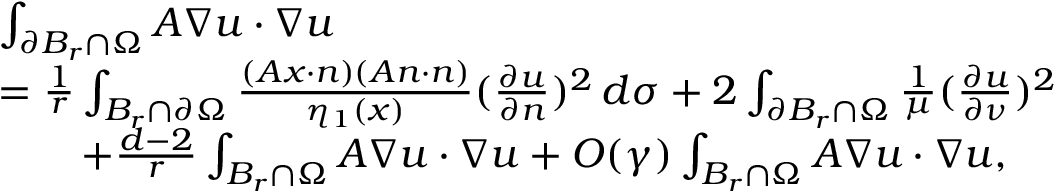<formula> <loc_0><loc_0><loc_500><loc_500>\begin{array} { r } { \begin{array} { r l } & { \int _ { \partial B _ { r } \cap \Omega } A \nabla u \cdot \nabla u } \\ & { = \frac { 1 } { r } \int _ { B _ { r } \cap \partial \Omega } \frac { ( A x \cdot n ) ( A n \cdot n ) } { \eta _ { 1 } ( x ) } ( \frac { \partial u } { \partial n } ) ^ { 2 } \, d \sigma + 2 \int _ { \partial B _ { r } \cap \Omega } \frac { 1 } { \mu } ( \frac { \partial u } { \partial \nu } ) ^ { 2 } } \\ & { \quad + \frac { d - 2 } { r } \int _ { B _ { r } \cap \Omega } A \nabla u \cdot \nabla u + O ( \gamma ) \int _ { B _ { r } \cap \Omega } A \nabla u \cdot \nabla u , } \end{array} } \end{array}</formula> 